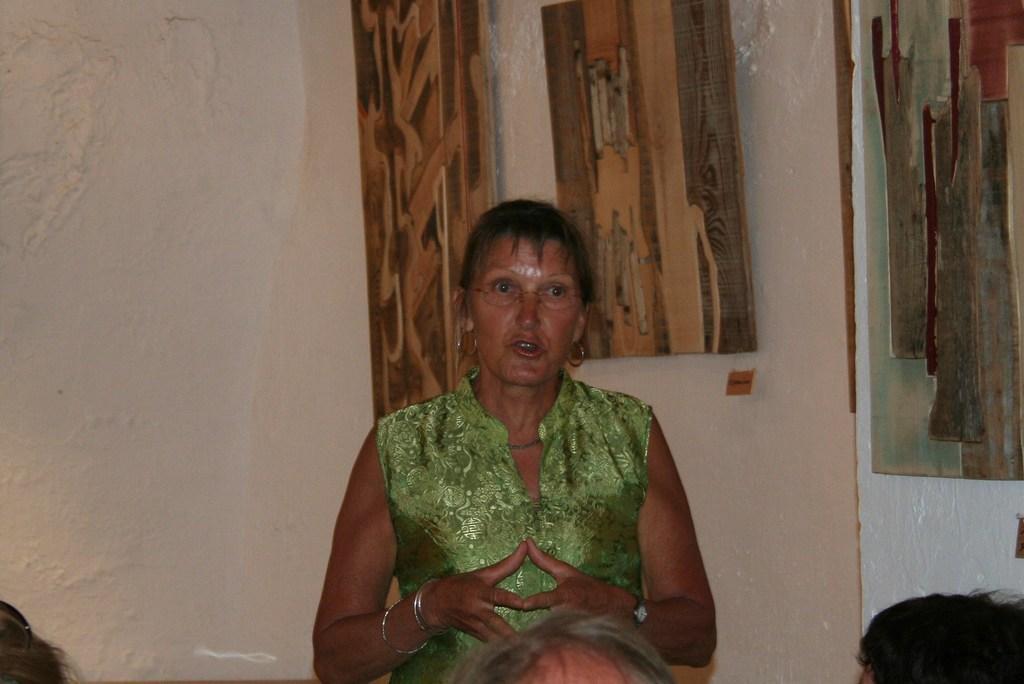In one or two sentences, can you explain what this image depicts? As we can see in the image there is a white color wall and few people. The woman over here is wearing green color dress. 